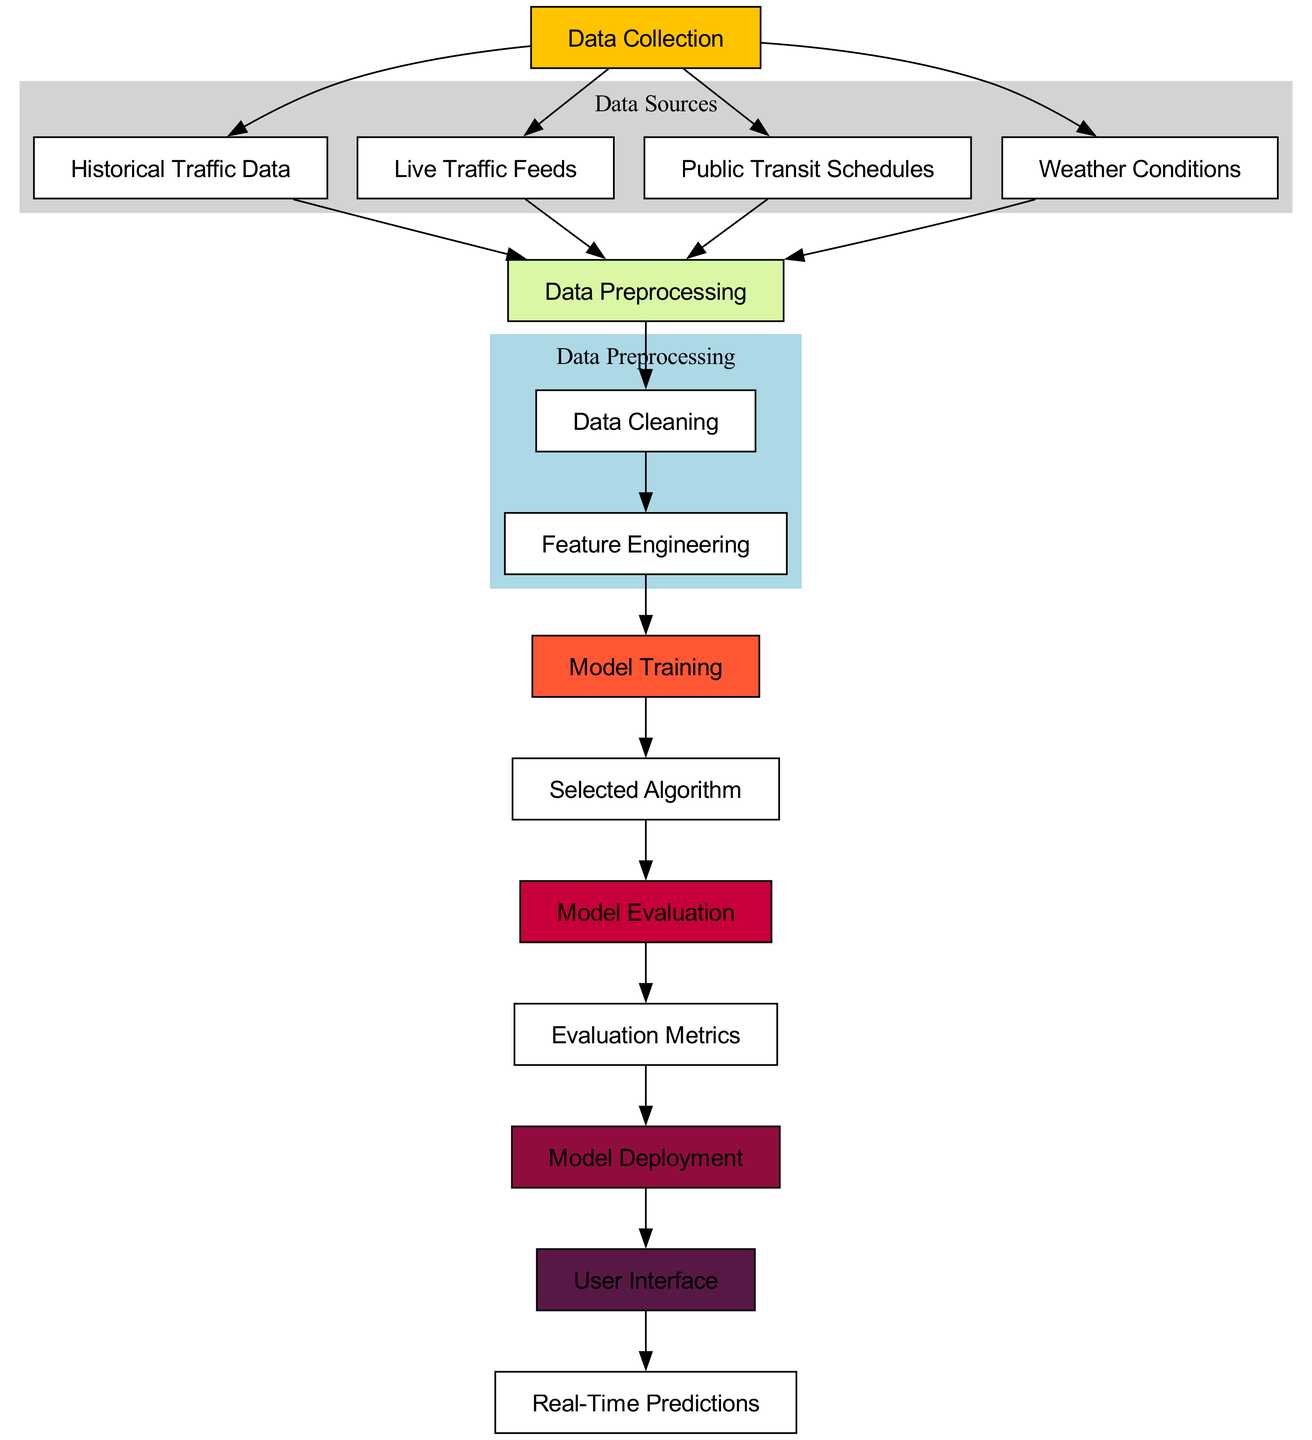What is the first step in the diagram? The diagram starts from the "Data Collection" node, which is the initial step where various types of traffic-related data are gathered.
Answer: Data Collection How many main sources of data are collected? There are four main sources of data indicated in the diagram: Historical Traffic Data, Live Traffic Feeds, Public Transit Schedules, and Weather Conditions.
Answer: Four Which node is connected to the Model Training node? The "Feature Engineering" node is connected to the "Model Training" node, indicating that feature extraction is required before training the model.
Answer: Feature Engineering What is the final output of the diagram? The final output of the diagram is represented by the "Real-Time Predictions" node, which indicates that the model provides predictions based on the processed data.
Answer: Real-Time Predictions Which type of data is cleaned before feature engineering? "Data Cleaning" happens after data preprocessing, ensuring that raw data is cleaned up before feature engineering takes place for better model training.
Answer: Historical Traffic Data, Live Traffic Feeds, Public Transit Schedules, Weather Conditions What connects the Evaluation Metrics to Model Deployment? The flow from "Evaluation Metrics" to "Model Deployment" suggests that the model's performance metrics determine whether it is ready for deployment.
Answer: Evaluation Metrics How many nodes are in the Data Preprocessing cluster? The Data Preprocessing cluster contains three nodes: "Data Preprocessing" itself, "Data Cleaning," and "Feature Engineering," indicating steps taken before model training.
Answer: Three What type of model is trained based on the selected algorithm? The "Model Training" node directly connects to the "Selected Algorithm" node, indicating that the model is trained using this chosen algorithm, which will differ depending on the traffic data context.
Answer: Selected Algorithm What is the role of the User Interface in this process? The "User Interface" node is connected to "Model Deployment" and indicates that it serves as the platform where users interact with the real-time predictions generated by the model.
Answer: User Interface 